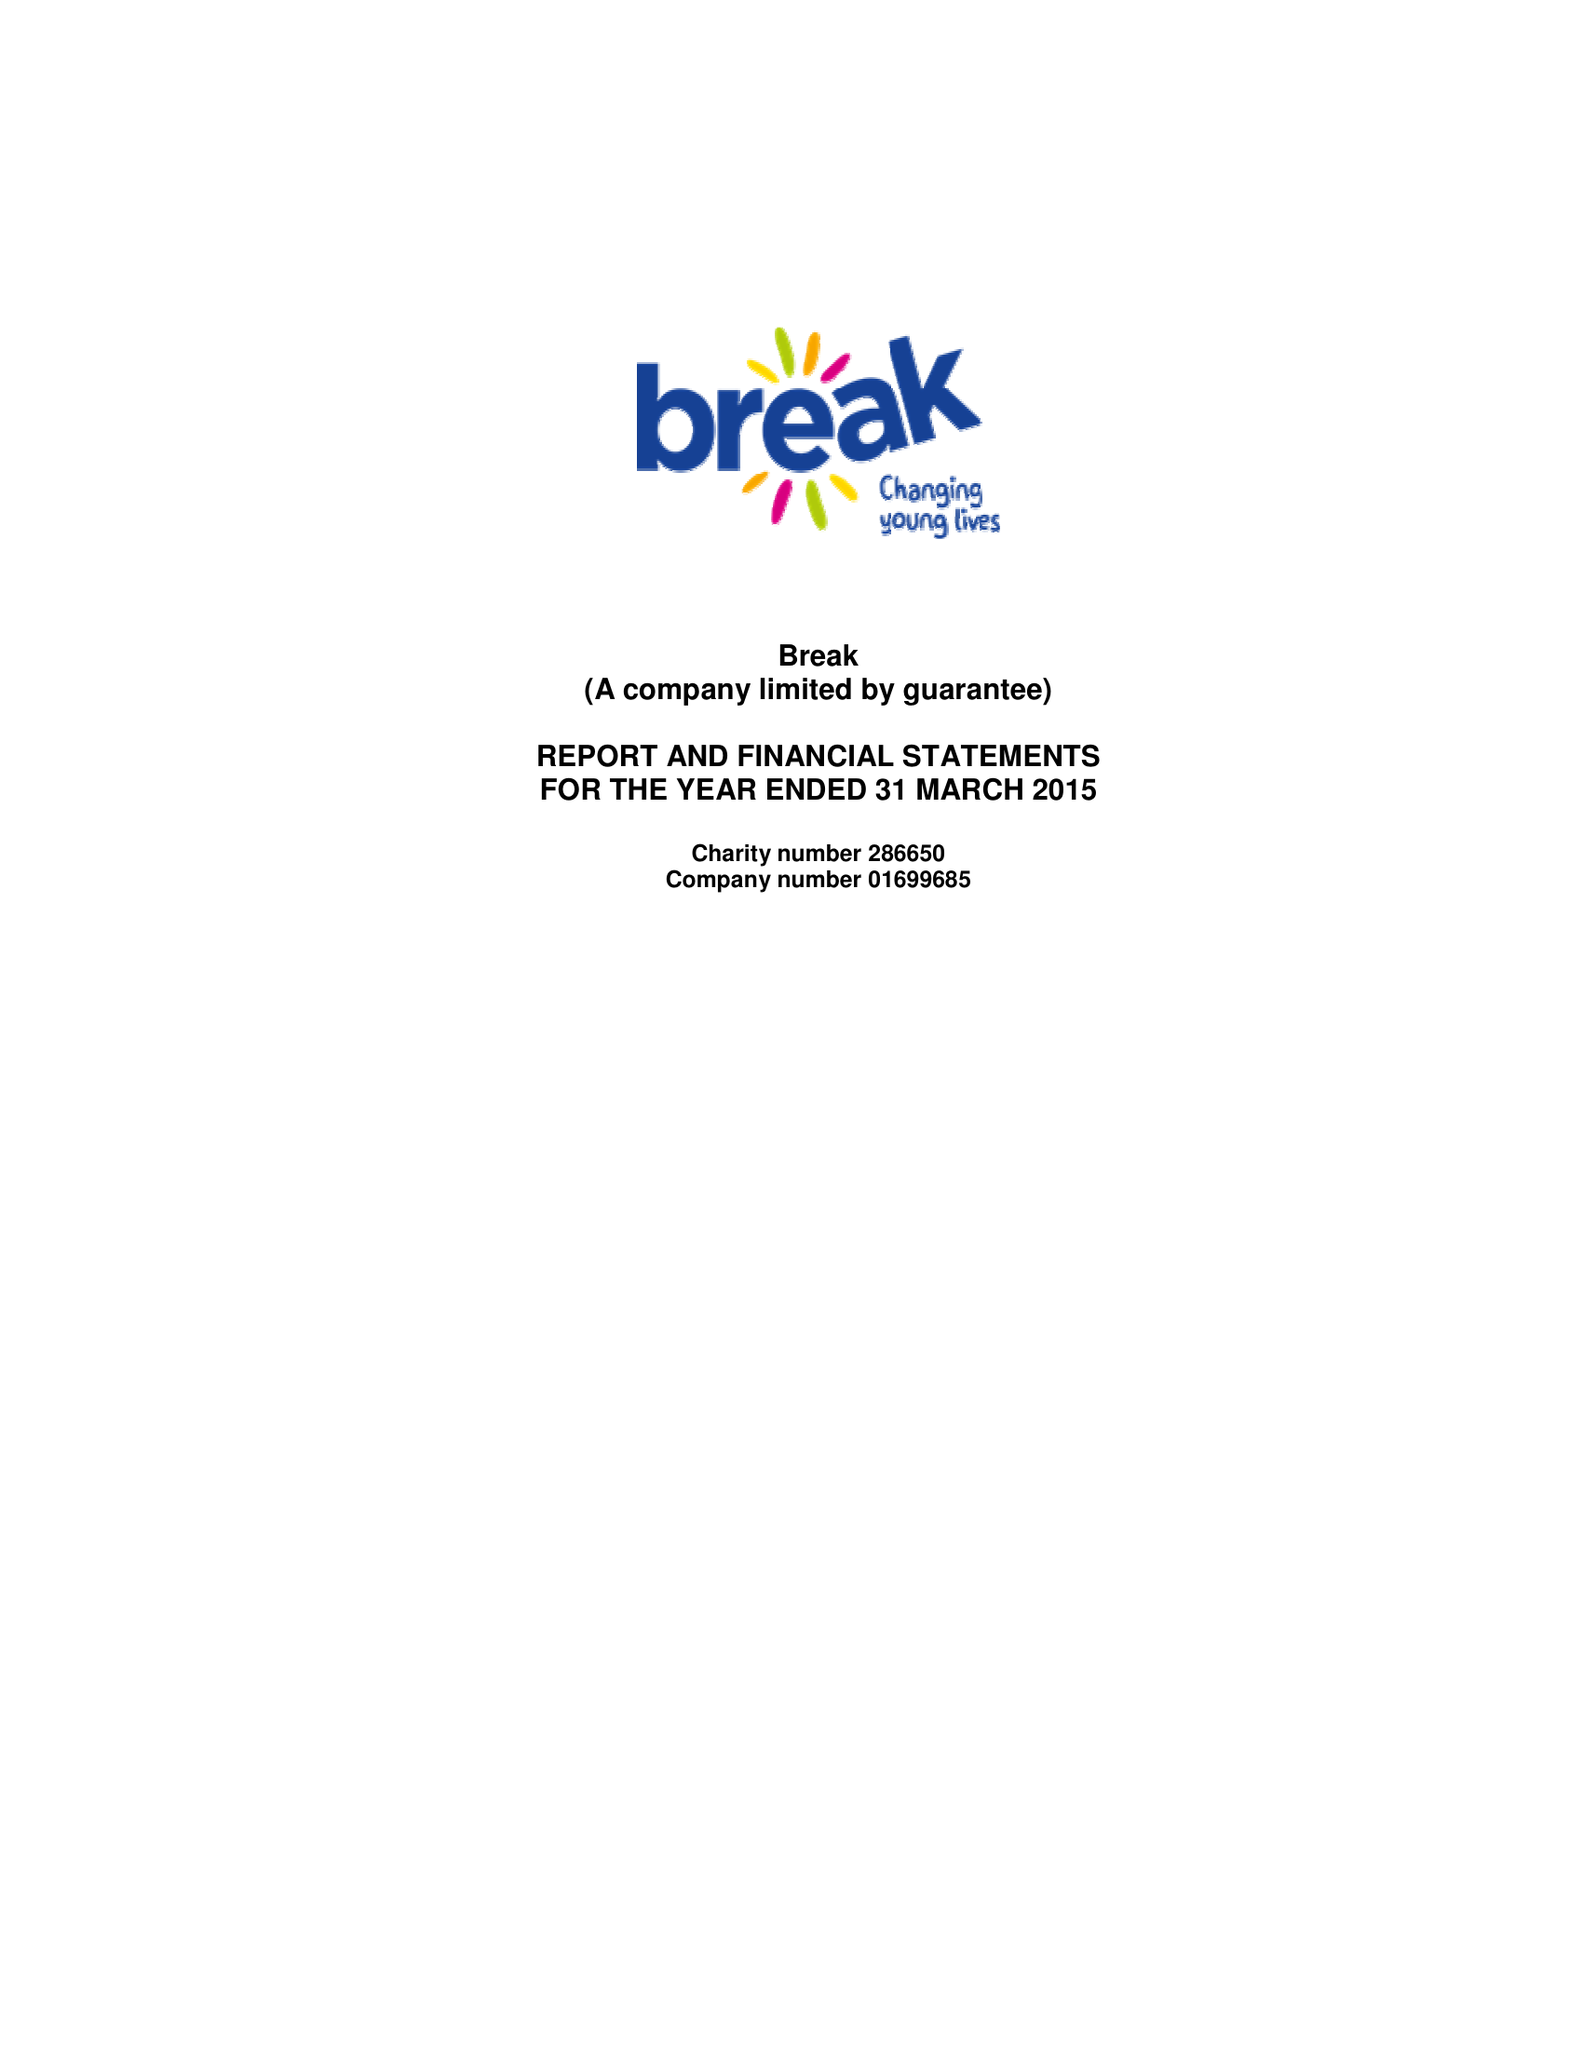What is the value for the address__post_town?
Answer the question using a single word or phrase. NORWICH 